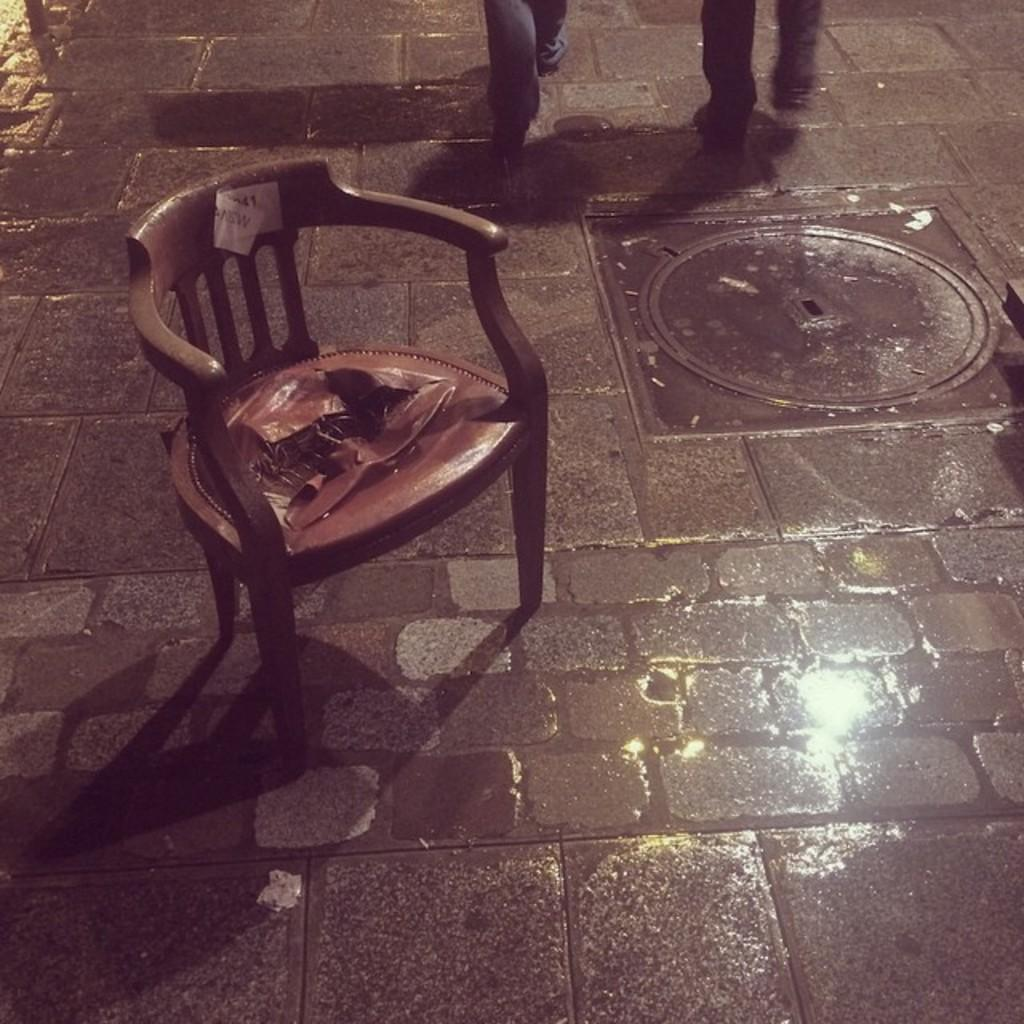What type of furniture is present in the image? There is a chair in the image. Where is the chair located? The chair is on the floor. What are the two people in the image doing? The two people are walking in the image. How can you tell that the people are walking? The people are exhibiting leg movement in the image. What type of boot is visible on the floor in the image? There is no boot present in the image. How many marbles are being held by the people in the image? There is no mention of marbles in the image; the people are walking and exhibiting leg movement. 